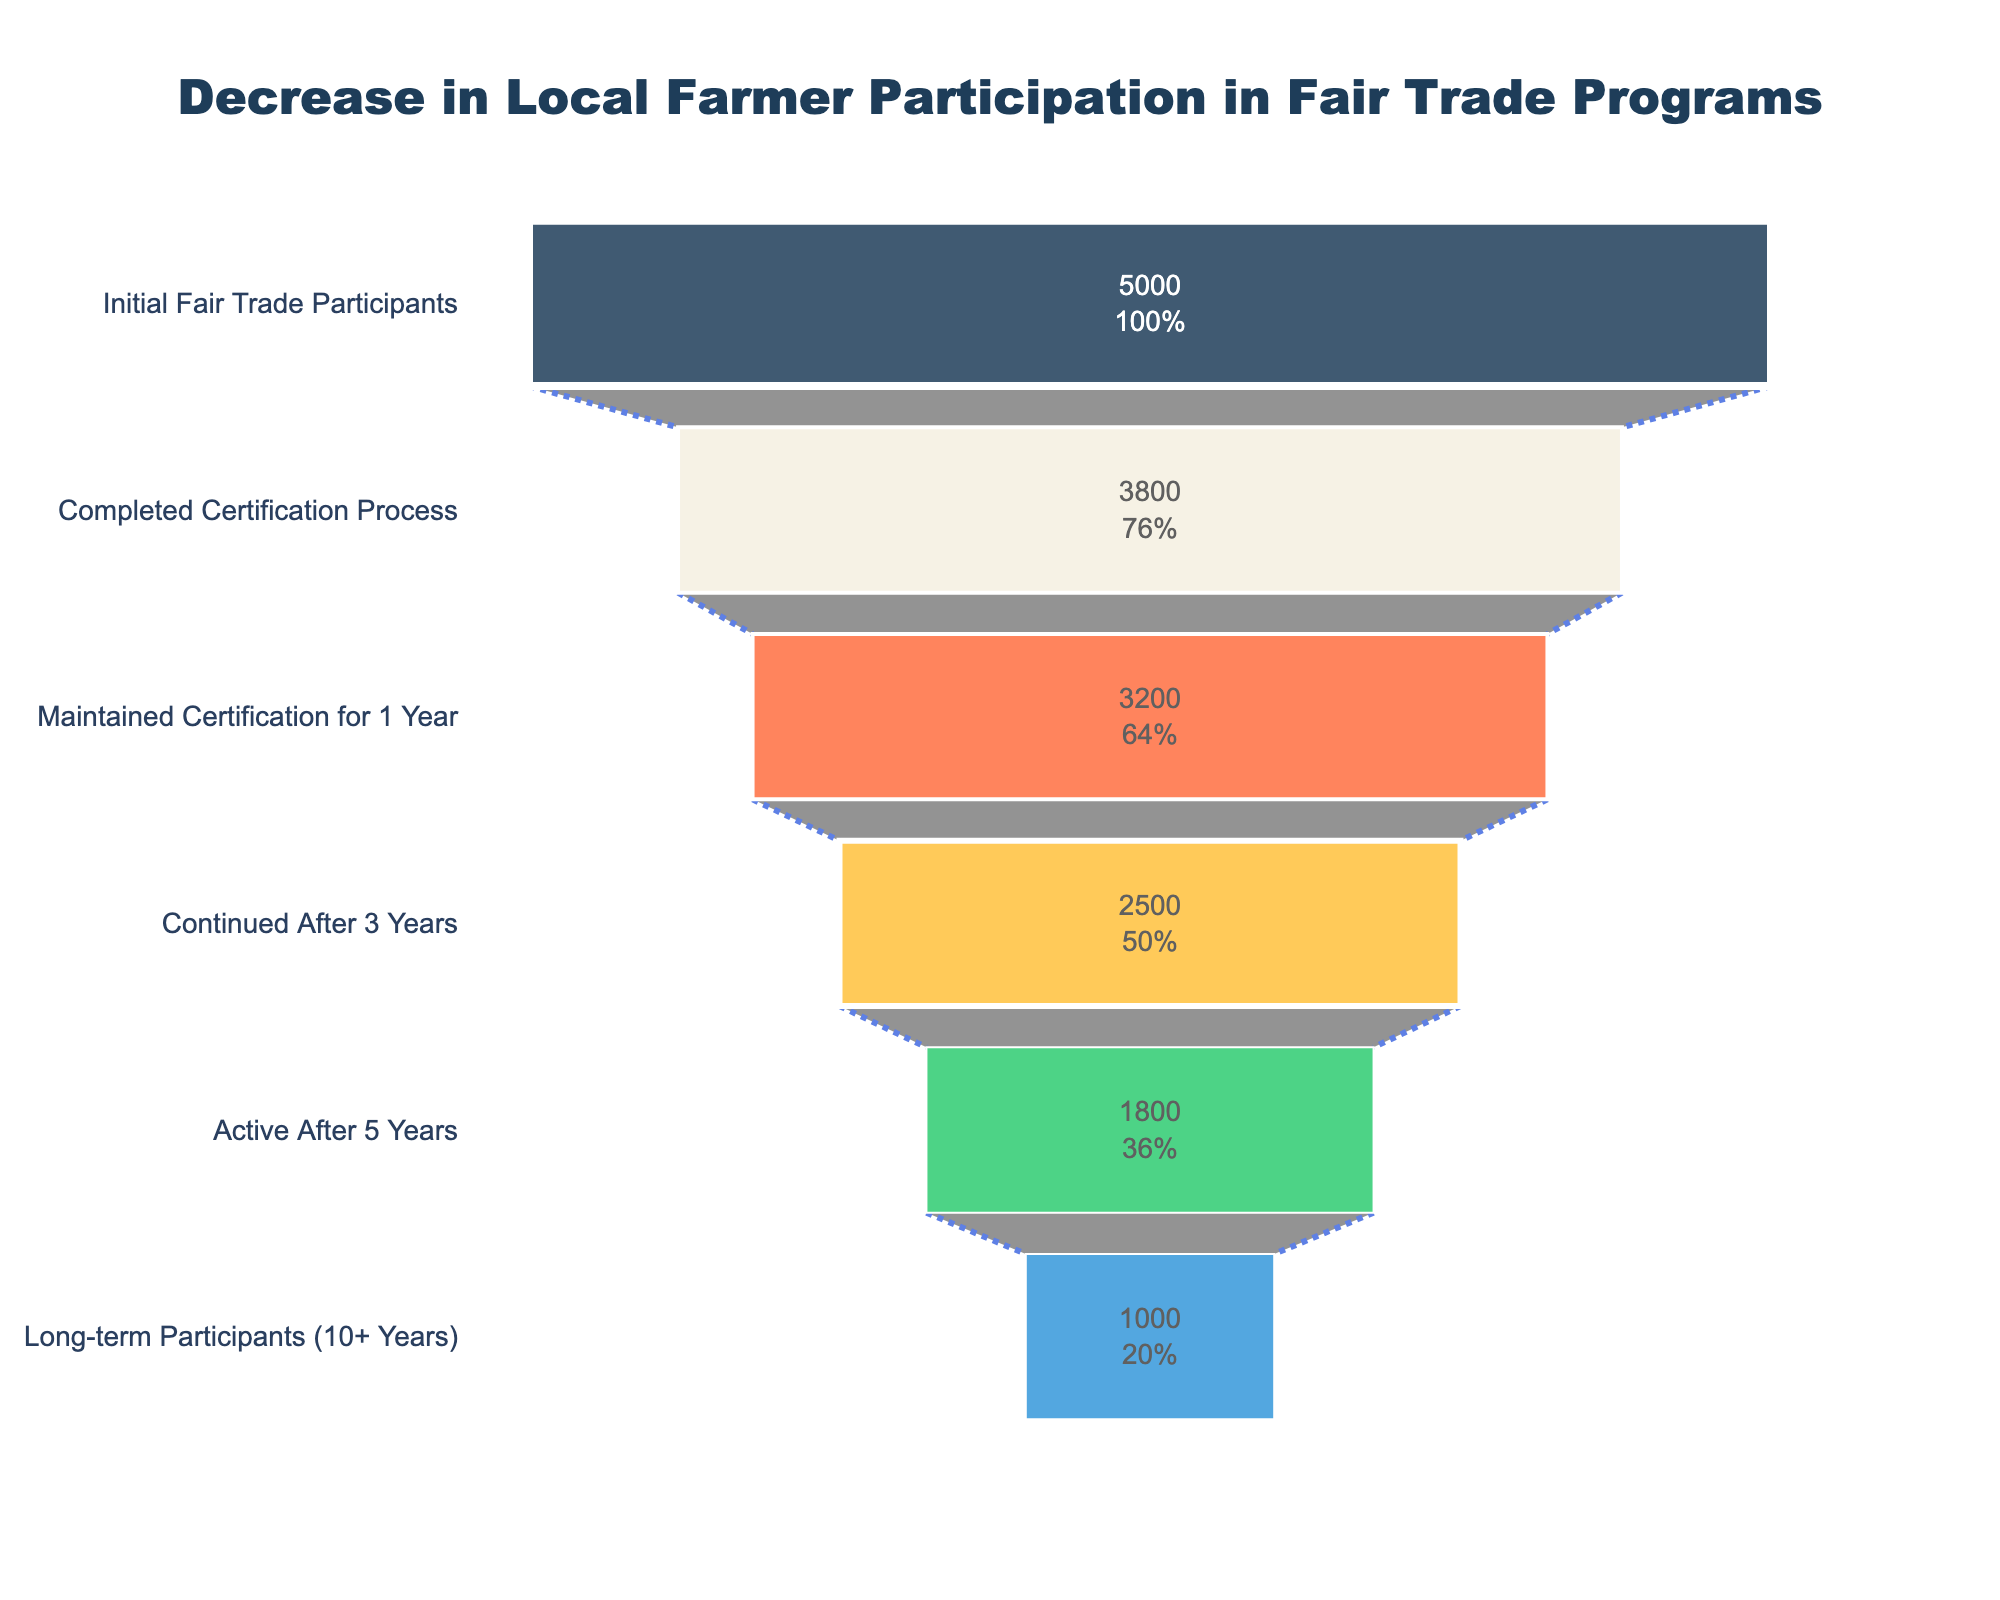what is the title of the funnel chart? The title of the chart is usually placed at the top and is the largest text element in the figure. It helps summarize what the chart is about. Here, it says "Decrease in Local Farmer Participation in Fair Trade Programs."
Answer: Decrease in Local Farmer Participation in Fair Trade Programs how many stages are there in the funnel chart? By looking at the y-axis labels, we can count the number of different stages listed. These stages are "Initial Fair Trade Participants", "Completed Certification Process", "Maintained Certification for 1 Year", "Continued After 3 Years", "Active After 5 Years", and "Long-term Participants (10+ Years)." There are 6 stages in total.
Answer: 6 what is the color of the first stage in the funnel? The color schemes are visible in the funnel segments. The first stage "Initial Fair Trade Participants" is colored with a dark blue shade.
Answer: Dark Blue how many farmers were Initial Fair Trade Participants? The value for "Initial Fair Trade Participants" is written inside the first funnel segment. It shows that 5000 farmers initially participated in the fair trade program.
Answer: 5000 what percentage of initial participants maintained certification for 1 year? In the funnel segment titled "Maintained Certification for 1 Year," the percentage is listed alongside the absolute number. It shows the value in both numbers and percentage terms, indicating how many maintained certification. The percentage for this stage is approximately 64%.
Answer: 64% how many farmers stopped participating between completing certification and maintaining certification for 1 year? To find this, subtract the number of farmers who maintained certification for 1 year from the number who completed the certification process: 3800 - 3200 = 600.
Answer: 600 which stage has the largest decrease in the number of farmers? By comparing the farmers' numbers between consecutive stages, the largest decrease is between "Maintained Certification for 1 Year" (3200) and "Continued After 3 Years" (2500). The decrease is 3200 - 2500 = 700.
Answer: Maintained Certification for 1 Year to Continued After 3 Years how many farmers become long-term participants after 10+ years? The value is given in the last segment of the funnel. It states that 1000 farmers are in the "Long-term Participants (10+ Years)" stage.
Answer: 1000 what is the percentage decrease in farmer participation from 5 years to 10+ years? To calculate this, find the difference and then convert it to a percentage of the initial 5-year value: (1800 - 1000) / 1800 * 100. The percentage decrease is approximately 44%.
Answer: 44% which stage shows a percentage value inside it that reflects the largest retention rate since the initial participation? By looking inside each segment, we can see that "Completed Certification Process" has the largest percentage value (76%), reflecting the highest retention rate from the initial participation of 5000 farmers.
Answer: Completed Certification Process 